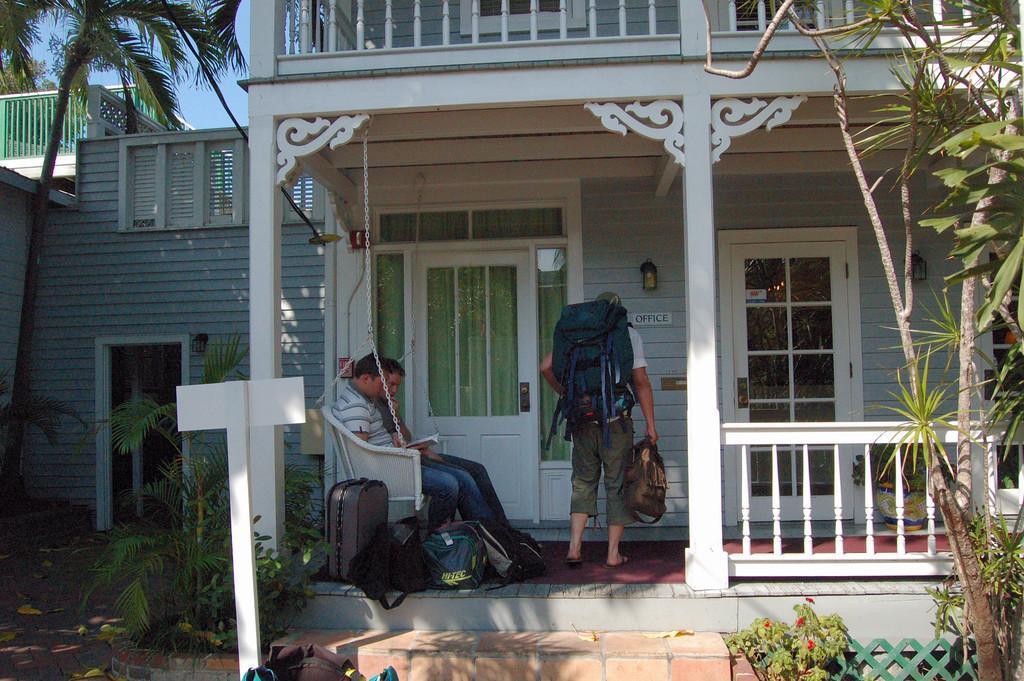Describe this image in one or two sentences. In this image there is a house in that house there is a sofa, in that two men are sitting and there is a luggage, one man is sitting and holding luggage and there are two doors, on the right side there are trees, on the left side there are trees. 